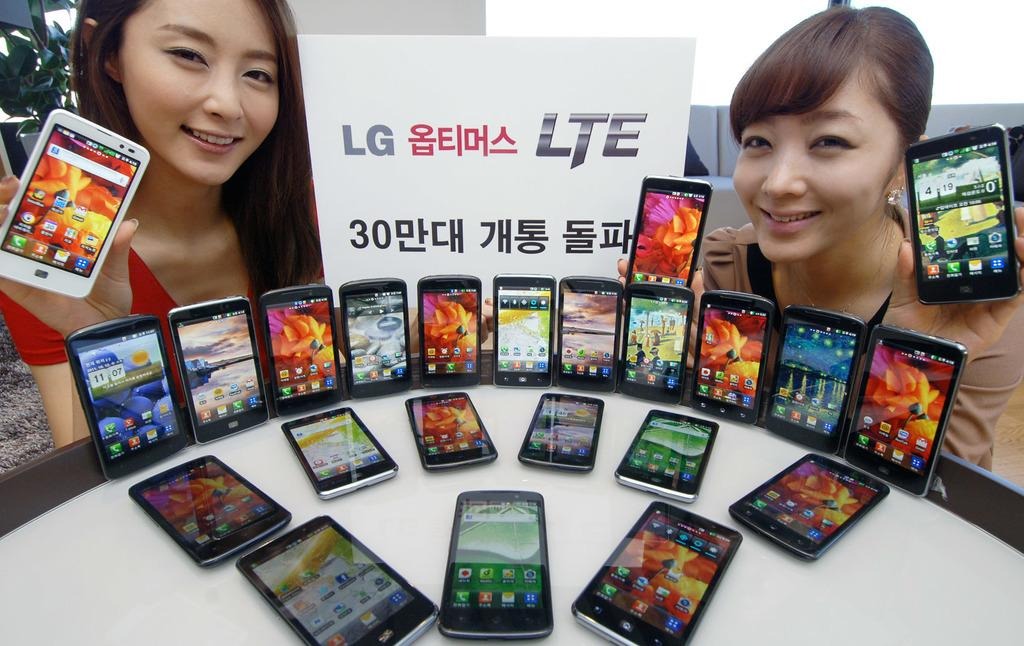Provide a one-sentence caption for the provided image. Two girls are holding cell phones by a table covered in phones with a sign that says LG LTE. 